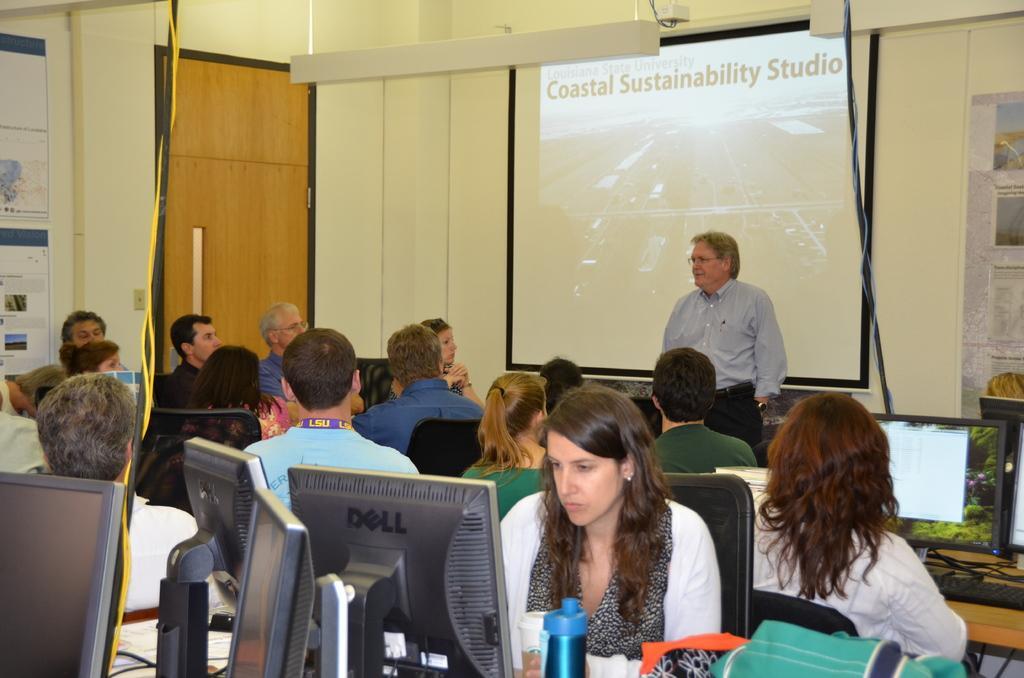In one or two sentences, can you explain what this image depicts? In this image there are people sitting on the chairs. In front of them there are tables. On top of it there are computers. On the left side of the image there is a closed door. In the background of the image there is a screen. In front of the screen there is a person. There are posters attached to the wall. 